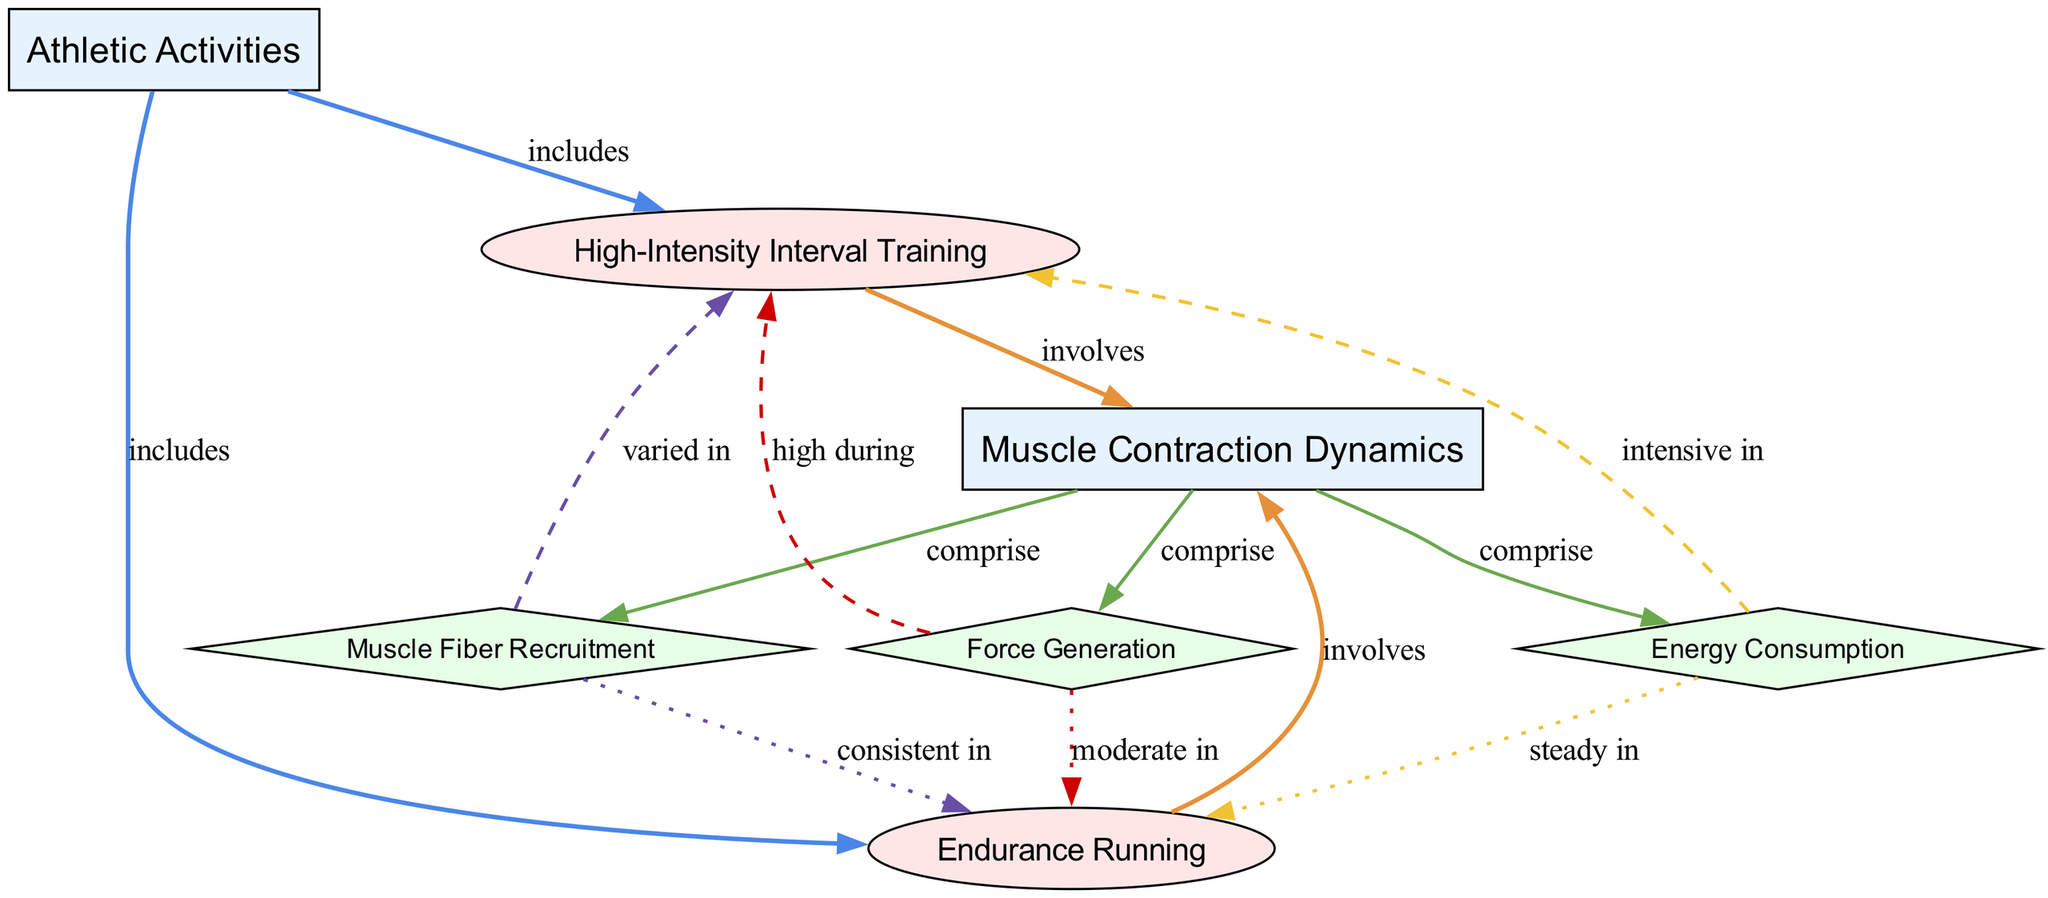What activities are included under Athletic Activities? The diagram shows two activities connected to the "Athletic Activities" node: "High-Intensity Interval Training" and "Endurance Running." Thus, these two activities are included under the category of Athletic Activities.
Answer: High-Intensity Interval Training, Endurance Running How many dynamic elements are represented in the diagram? The diagram categorizes three dynamic elements under "Muscle Contraction Dynamics": "Force Generation," "Muscle Fiber Recruitment," and "Energy Consumption." Therefore, there are three dynamic elements in the diagram.
Answer: 3 Which activity involves high force generation? According to the diagram, "High-Intensity Interval Training" is the activity that is labeled as "high during" in relation to "Force Generation." Thus, it is the activity that involves high force generation.
Answer: High-Intensity Interval Training What describes muscle fiber recruitment during Endurance Running? The diagram indicates that "Muscle Fiber Recruitment" is "consistent in" relation to "Endurance Running." This relationship shows how muscle fiber recruitment behaves during this specific activity.
Answer: Consistent Which energy consumption pattern is associated with High-Intensity Interval Training? The diagram indicates that "Energy Consumption" is described as "intensive in" when referring to "High-Intensity Interval Training." This provides insight into how energy consumption fluctuates during this intense activity.
Answer: Intensive How is muscle fiber recruitment varying in High-Intensity Interval Training? The diagram specifies that "Muscle Fiber Recruitment" is "varied in" relation to "High-Intensity Interval Training." This indicates that the recruitment of muscle fibers changes during this specific activity.
Answer: Varied What kind of relation exists between Force Generation and Endurance Running? The diagram portrays "Force Generation" as being "moderate in" relation to "Endurance Running." This suggests that the level of force generation is moderate during this endurance activity.
Answer: Moderate Which dynamic metric is primarily focused on during athletic activities? The diagram groups "Force Generation," "Muscle Fiber Recruitment," and "Energy Consumption" under "Muscle Contraction Dynamics," indicating they are all primary focuses during athletic activities regarding dynamic metrics.
Answer: Force Generation, Muscle Fiber Recruitment, Energy Consumption 